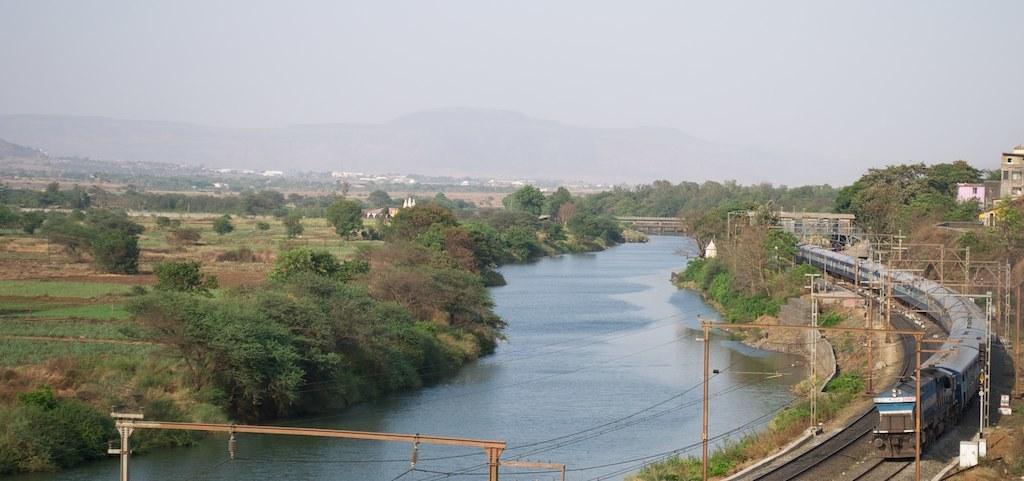Please provide a concise description of this image. On the right side of the image there is a train on the track. And also there are electrical poles with wires. And on the right corner of the image there are houses. At the bottom of the image in the middle there is water. Above the water there is a bridge. On the left side of the image on the ground there is grass and also there are trees. In the background there are houses and hills. At the top of the image there is sky. 